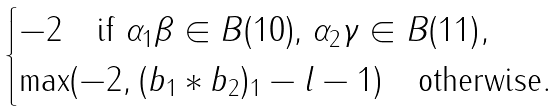Convert formula to latex. <formula><loc_0><loc_0><loc_500><loc_500>\begin{cases} - 2 \quad \text {if $\alpha_{1}\beta\in B(10)$, $\alpha_{2}\gamma\in B(11)$} , \\ \max ( - 2 , ( b _ { 1 } * b _ { 2 } ) _ { 1 } - l - 1 ) \quad \text {otherwise} . \end{cases}</formula> 